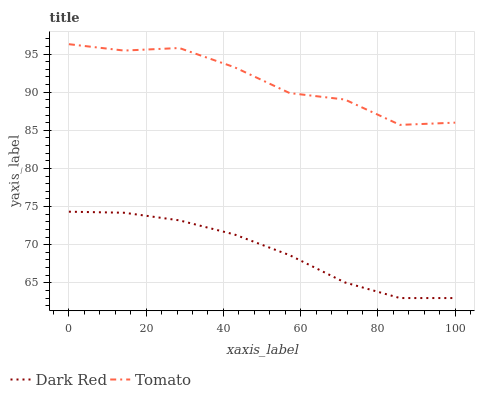Does Dark Red have the minimum area under the curve?
Answer yes or no. Yes. Does Tomato have the maximum area under the curve?
Answer yes or no. Yes. Does Dark Red have the maximum area under the curve?
Answer yes or no. No. Is Dark Red the smoothest?
Answer yes or no. Yes. Is Tomato the roughest?
Answer yes or no. Yes. Is Dark Red the roughest?
Answer yes or no. No. Does Dark Red have the lowest value?
Answer yes or no. Yes. Does Tomato have the highest value?
Answer yes or no. Yes. Does Dark Red have the highest value?
Answer yes or no. No. Is Dark Red less than Tomato?
Answer yes or no. Yes. Is Tomato greater than Dark Red?
Answer yes or no. Yes. Does Dark Red intersect Tomato?
Answer yes or no. No. 